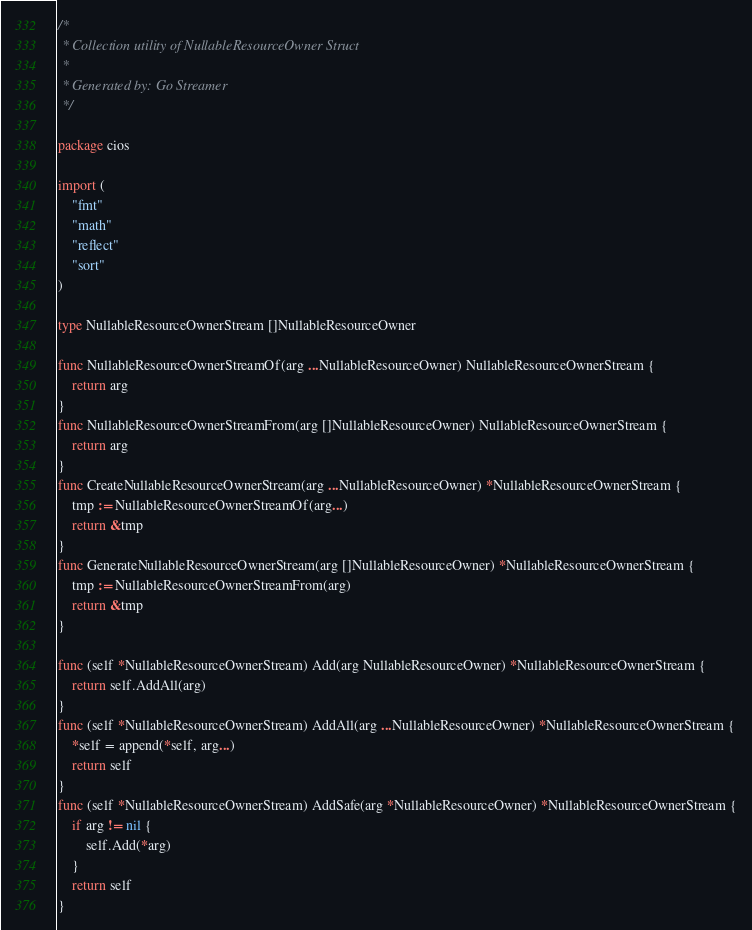Convert code to text. <code><loc_0><loc_0><loc_500><loc_500><_Go_>/*
 * Collection utility of NullableResourceOwner Struct
 *
 * Generated by: Go Streamer
 */

package cios

import (
	"fmt"
	"math"
	"reflect"
	"sort"
)

type NullableResourceOwnerStream []NullableResourceOwner

func NullableResourceOwnerStreamOf(arg ...NullableResourceOwner) NullableResourceOwnerStream {
	return arg
}
func NullableResourceOwnerStreamFrom(arg []NullableResourceOwner) NullableResourceOwnerStream {
	return arg
}
func CreateNullableResourceOwnerStream(arg ...NullableResourceOwner) *NullableResourceOwnerStream {
	tmp := NullableResourceOwnerStreamOf(arg...)
	return &tmp
}
func GenerateNullableResourceOwnerStream(arg []NullableResourceOwner) *NullableResourceOwnerStream {
	tmp := NullableResourceOwnerStreamFrom(arg)
	return &tmp
}

func (self *NullableResourceOwnerStream) Add(arg NullableResourceOwner) *NullableResourceOwnerStream {
	return self.AddAll(arg)
}
func (self *NullableResourceOwnerStream) AddAll(arg ...NullableResourceOwner) *NullableResourceOwnerStream {
	*self = append(*self, arg...)
	return self
}
func (self *NullableResourceOwnerStream) AddSafe(arg *NullableResourceOwner) *NullableResourceOwnerStream {
	if arg != nil {
		self.Add(*arg)
	}
	return self
}</code> 